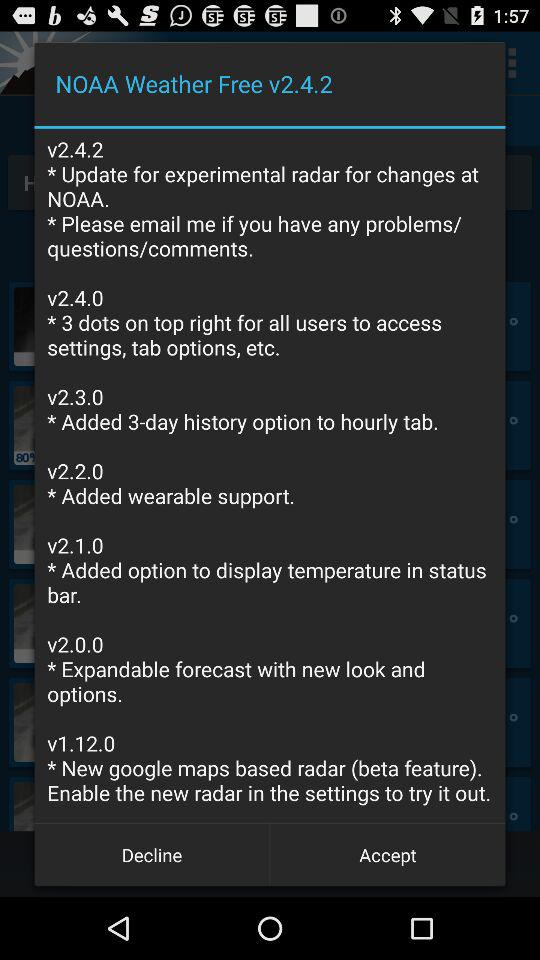Which version has the "Added wearable support" feature? The version that has the "Added wearable support" feature is v2.2.0. 